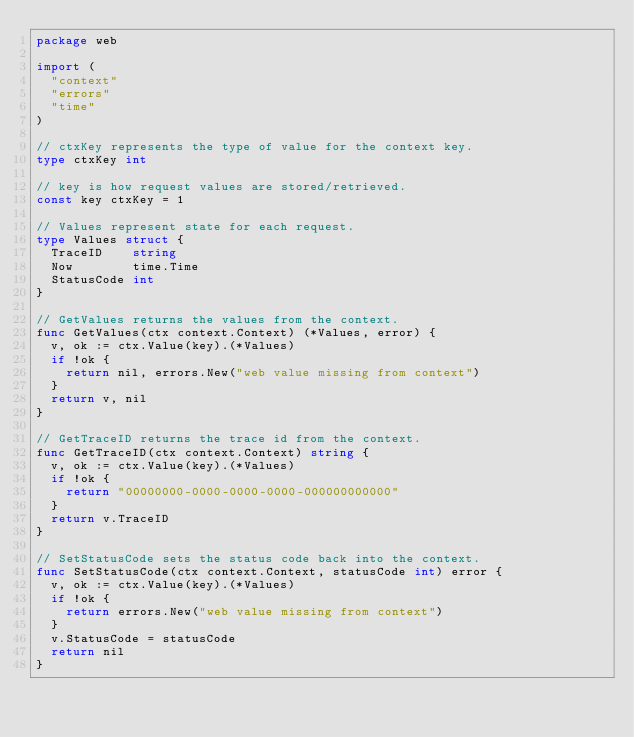Convert code to text. <code><loc_0><loc_0><loc_500><loc_500><_Go_>package web

import (
	"context"
	"errors"
	"time"
)

// ctxKey represents the type of value for the context key.
type ctxKey int

// key is how request values are stored/retrieved.
const key ctxKey = 1

// Values represent state for each request.
type Values struct {
	TraceID    string
	Now        time.Time
	StatusCode int
}

// GetValues returns the values from the context.
func GetValues(ctx context.Context) (*Values, error) {
	v, ok := ctx.Value(key).(*Values)
	if !ok {
		return nil, errors.New("web value missing from context")
	}
	return v, nil
}

// GetTraceID returns the trace id from the context.
func GetTraceID(ctx context.Context) string {
	v, ok := ctx.Value(key).(*Values)
	if !ok {
		return "00000000-0000-0000-0000-000000000000"
	}
	return v.TraceID
}

// SetStatusCode sets the status code back into the context.
func SetStatusCode(ctx context.Context, statusCode int) error {
	v, ok := ctx.Value(key).(*Values)
	if !ok {
		return errors.New("web value missing from context")
	}
	v.StatusCode = statusCode
	return nil
}
</code> 